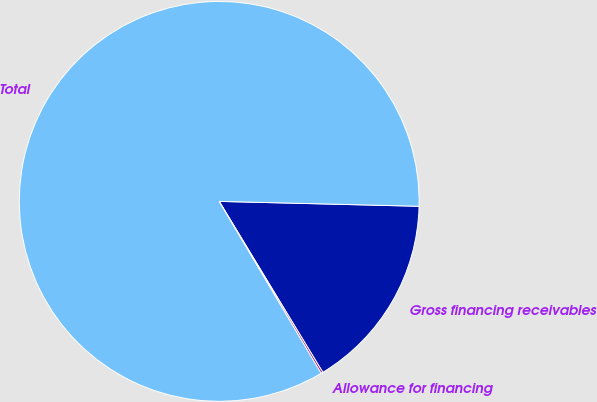<chart> <loc_0><loc_0><loc_500><loc_500><pie_chart><fcel>Gross financing receivables<fcel>Total<fcel>Allowance for financing<nl><fcel>15.94%<fcel>83.91%<fcel>0.15%<nl></chart> 